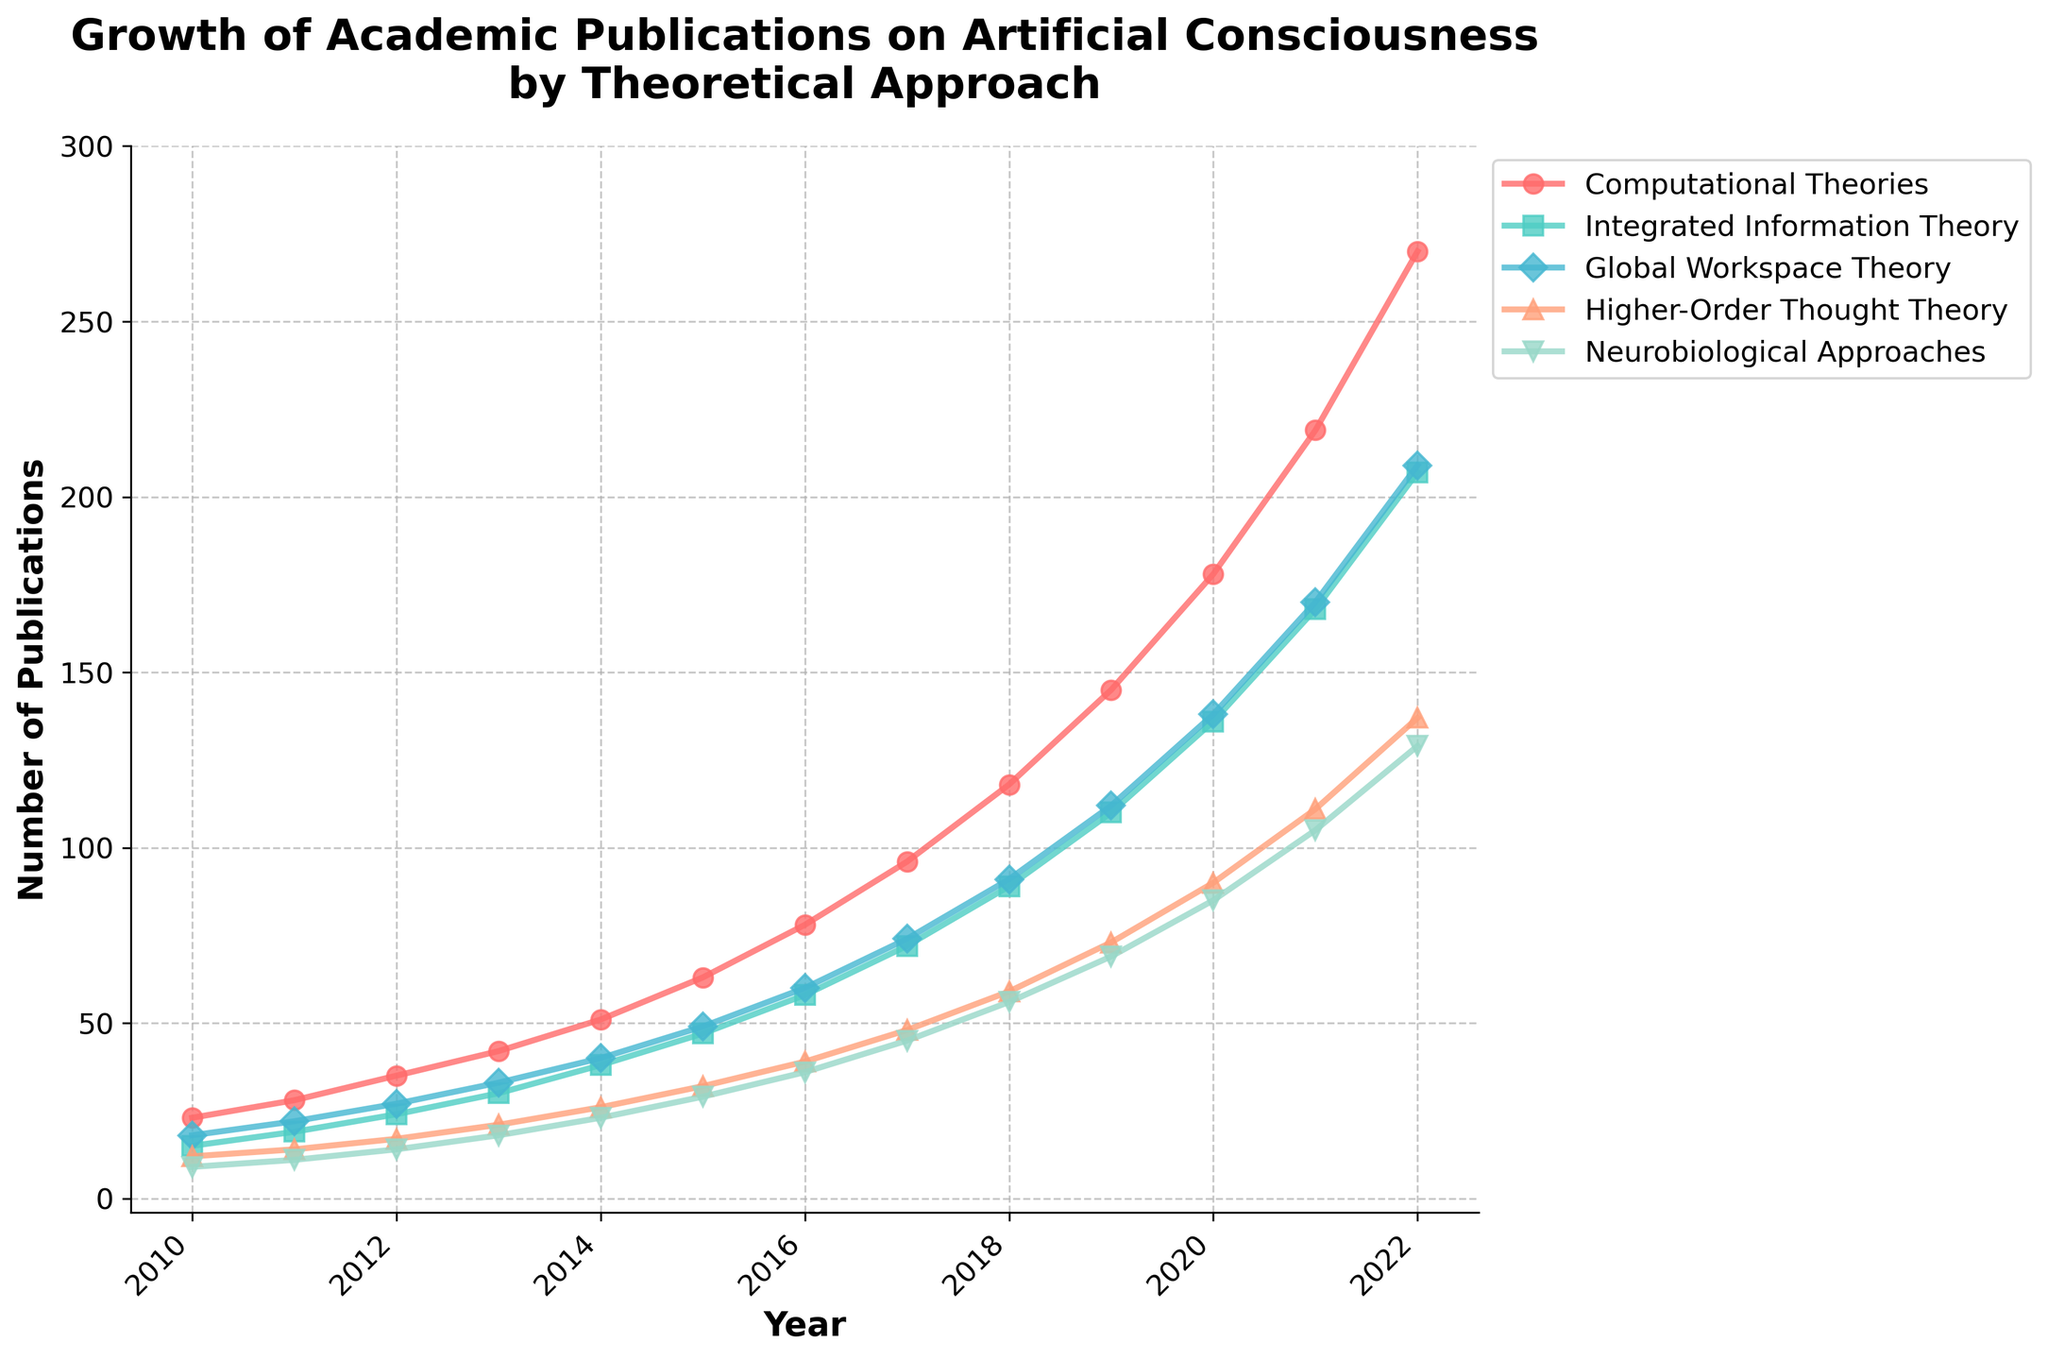What is the trend for the Computational Theories publications from 2010 to 2022? The line for Computational Theories publications shows a consistent upward trend from 2010 (23 publications) to 2022 (270 publications). This indicates a steady increase in interest and research in this theoretical approach.
Answer: Consistent upward trend Which theoretical approach had the least number of publications in 2010? In 2010, the Neurobiological Approaches had the least number of publications, with 9 publications. This is indicated by the lowest starting point on the y-axis for that year.
Answer: Neurobiological Approaches By how much did the publications for the Global Workspace Theory increase from 2010 to 2022? In 2010, there were 18 publications in the Global Workspace Theory, which increased to 209 in 2022. The increase is calculated as 209 - 18 = 191.
Answer: 191 Which theoretical approach had the fastest growth in publications between 2010 and 2022? To determine the fastest growth, we compare the publication numbers in 2010 and 2022 for each theoretical approach. Computational Theories grew from 23 to 270; Integrated Information Theory from 15 to 207; Global Workspace Theory from 18 to 209; Higher-Order Thought Theory from 12 to 137; Neurobiological Approaches from 9 to 129. Computational Theories had the highest absolute increase.
Answer: Computational Theories In what year did Integrated Information Theory surpass 100 publications? From the figure, Integrated Information Theory surpassed 100 publications in 2019, indicated by the publication number of 110.
Answer: 2019 Compare the publication numbers for Neurobiological Approaches and Higher-Order Thought Theory in 2020. Which one had more publications? In 2020, Higher-Order Thought Theory had 90 publications, and Neurobiological Approaches had 85 publications. Therefore, Higher-Order Thought Theory had more publications.
Answer: Higher-Order Thought Theory What is the total number of publications for all theoretical approaches combined in the year 2015? The number of publications for 2015 for each approach is: Computational Theories 63, Integrated Information Theory 47, Global Workspace Theory 49, Higher-Order Thought Theory 32, and Neurobiological Approaches 29. The total is 63 + 47 + 49 + 32 + 29 = 220.
Answer: 220 What's the average annual increase in publications for Higher-Order Thought Theory from 2010 to 2022? To find the average annual increase, first calculate the total increase from 2010 to 2022: 137 - 12 = 125. The time span is 2022 - 2010 = 12 years. Therefore, the average annual increase is 125 / 12 ≈ 10.42.
Answer: 10.42 How did the growth rate of publications for Computational Theories compare to that of Integrated Information Theory between 2017 and 2020? In 2017, Computational Theories had 96 publications and in 2020, it had 178. For Integrated Information Theory, the numbers were 72 in 2017 and 136 in 2020. The growth for Computational Theories is 178 - 96 = 82, and for Integrated Information Theory, it is 136 - 72 = 64. Hence, Computational Theories had a higher growth rate.
Answer: Computational Theories grew faster 